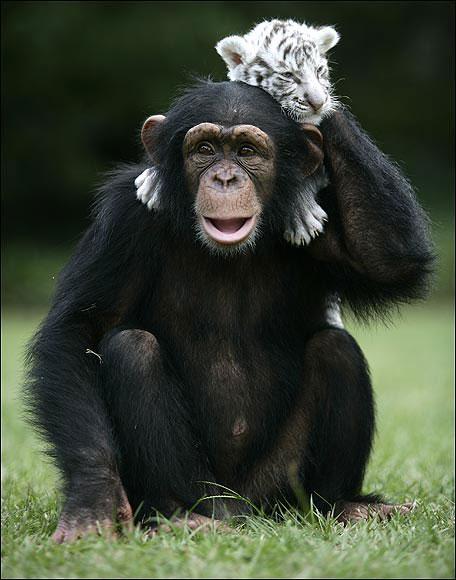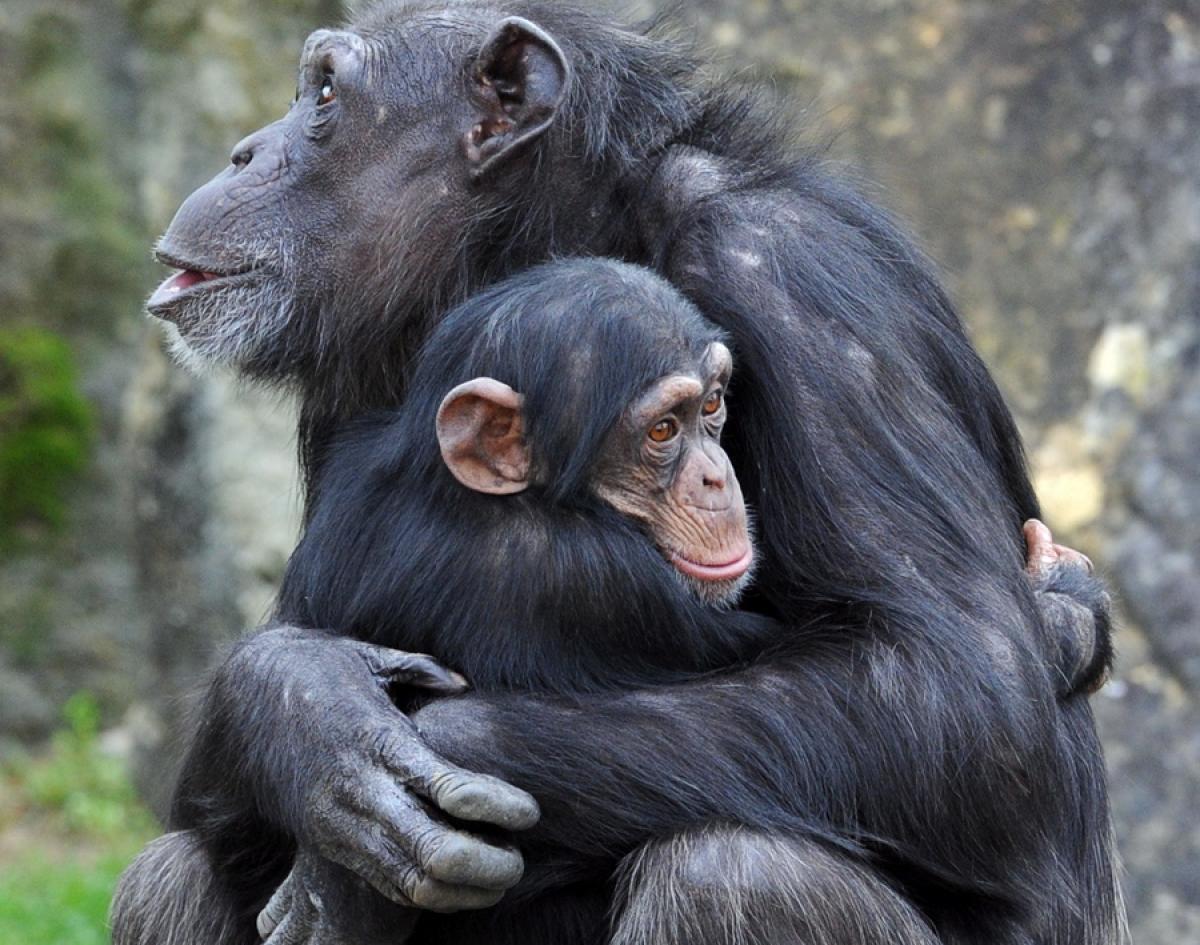The first image is the image on the left, the second image is the image on the right. For the images shown, is this caption "An image shows an adult and a younger chimp chest to chest in a hugging pose." true? Answer yes or no. Yes. The first image is the image on the left, the second image is the image on the right. For the images displayed, is the sentence "In one image, two chimpanzees are hugging, while one chimpanzee in a second image has its left arm raised to head level." factually correct? Answer yes or no. Yes. 